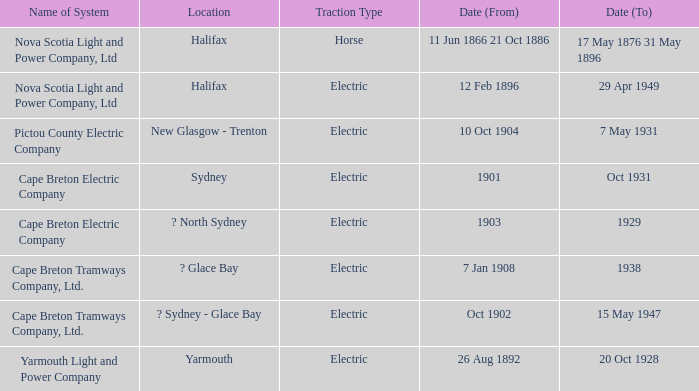What is the date (to) associated wiht a traction type of electric and the Yarmouth Light and Power Company system? 20 Oct 1928. 